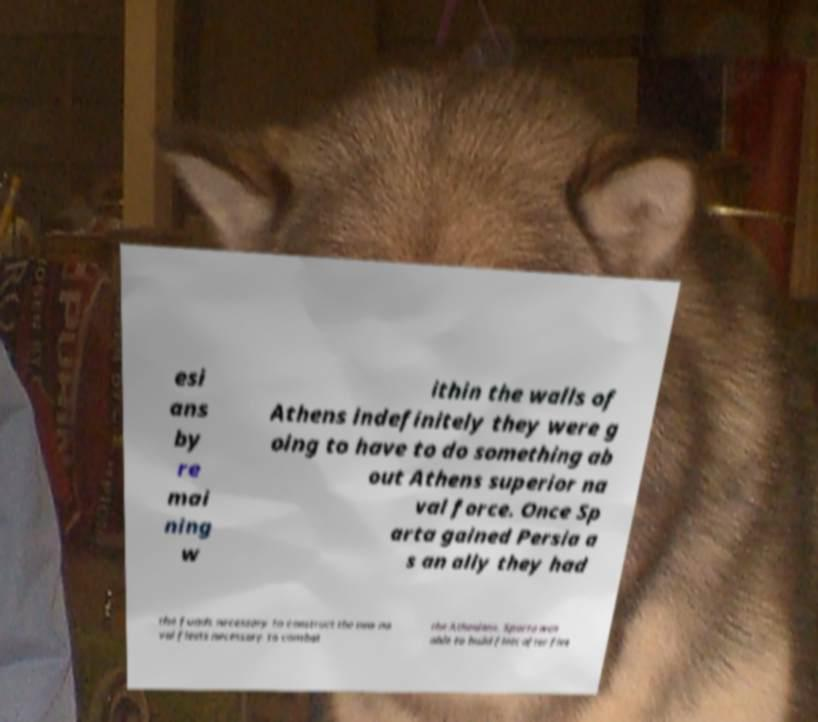Could you assist in decoding the text presented in this image and type it out clearly? esi ans by re mai ning w ithin the walls of Athens indefinitely they were g oing to have to do something ab out Athens superior na val force. Once Sp arta gained Persia a s an ally they had the funds necessary to construct the new na val fleets necessary to combat the Athenians. Sparta was able to build fleet after flee 